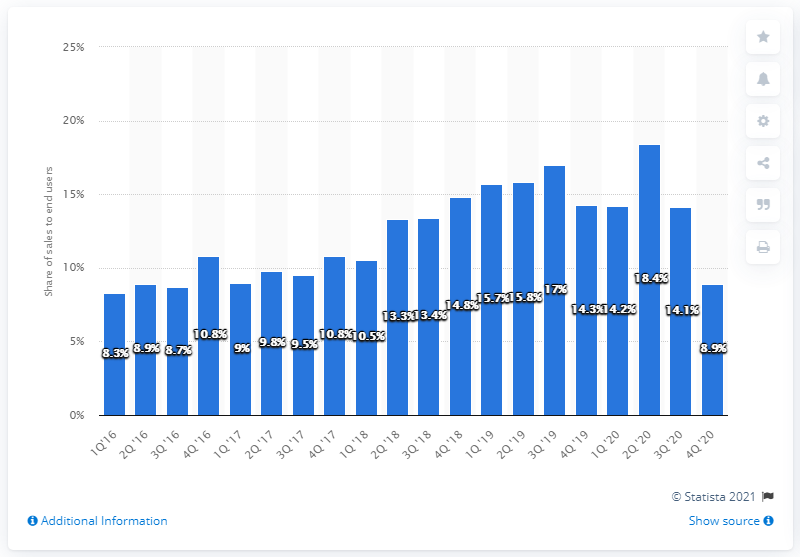Highlight a few significant elements in this photo. In Q1 2016, Huawei accounted for 8.3% of all smartphones sold to end users. Huawei had a market share of 8.9% in the fourth quarter of 2020. Huawei held a market share of 18.4% in Q2 2020. 